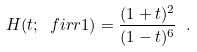<formula> <loc_0><loc_0><loc_500><loc_500>H ( t ; \ f i r r { 1 } ) = \frac { ( 1 + t ) ^ { 2 } } { ( 1 - t ) ^ { 6 } } \ .</formula> 